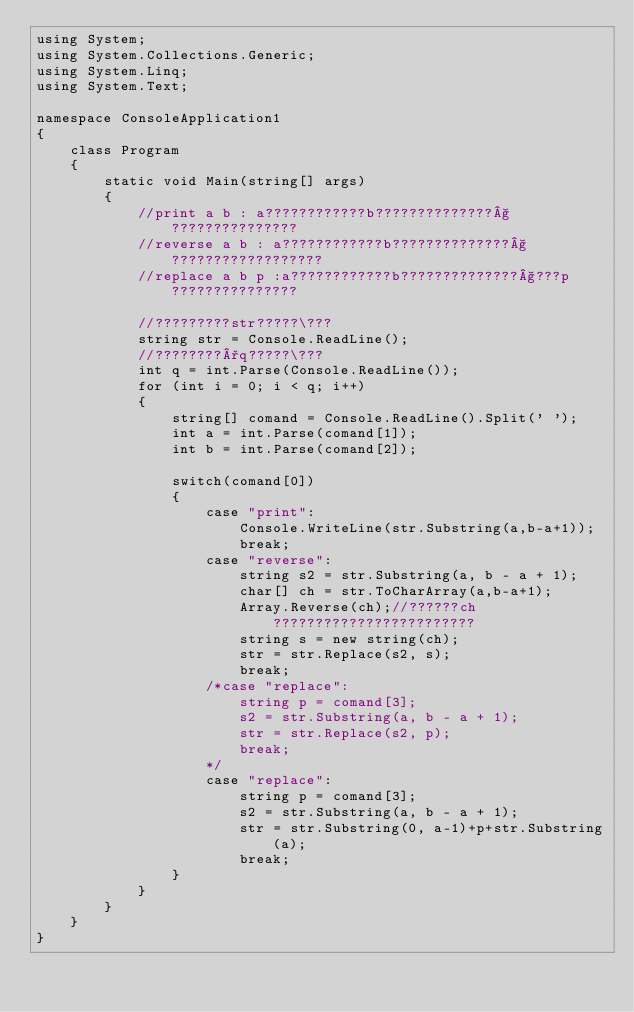Convert code to text. <code><loc_0><loc_0><loc_500><loc_500><_C#_>using System;
using System.Collections.Generic;
using System.Linq;
using System.Text;

namespace ConsoleApplication1
{
    class Program
    {
        static void Main(string[] args)
        {
            //print a b : a????????????b??????????????§???????????????
            //reverse a b : a????????????b??????????????§??????????????????
            //replace a b p :a????????????b??????????????§???p???????????????

            //?????????str?????\???
            string str = Console.ReadLine();
            //????????°q?????\???
            int q = int.Parse(Console.ReadLine());
            for (int i = 0; i < q; i++)
            {
                string[] comand = Console.ReadLine().Split(' ');
                int a = int.Parse(comand[1]);
                int b = int.Parse(comand[2]);

                switch(comand[0])
                {
                    case "print":
                        Console.WriteLine(str.Substring(a,b-a+1));
                        break;
                    case "reverse":
                        string s2 = str.Substring(a, b - a + 1);
                        char[] ch = str.ToCharArray(a,b-a+1);
                        Array.Reverse(ch);//??????ch????????????????????????
                        string s = new string(ch);
                        str = str.Replace(s2, s);
                        break;
                    /*case "replace":
                        string p = comand[3];
                        s2 = str.Substring(a, b - a + 1);
                        str = str.Replace(s2, p);
                        break;
                    */
                    case "replace":
                        string p = comand[3];
                        s2 = str.Substring(a, b - a + 1);
                        str = str.Substring(0, a-1)+p+str.Substring(a);
                        break;
                }
            }
        }
    }
}</code> 